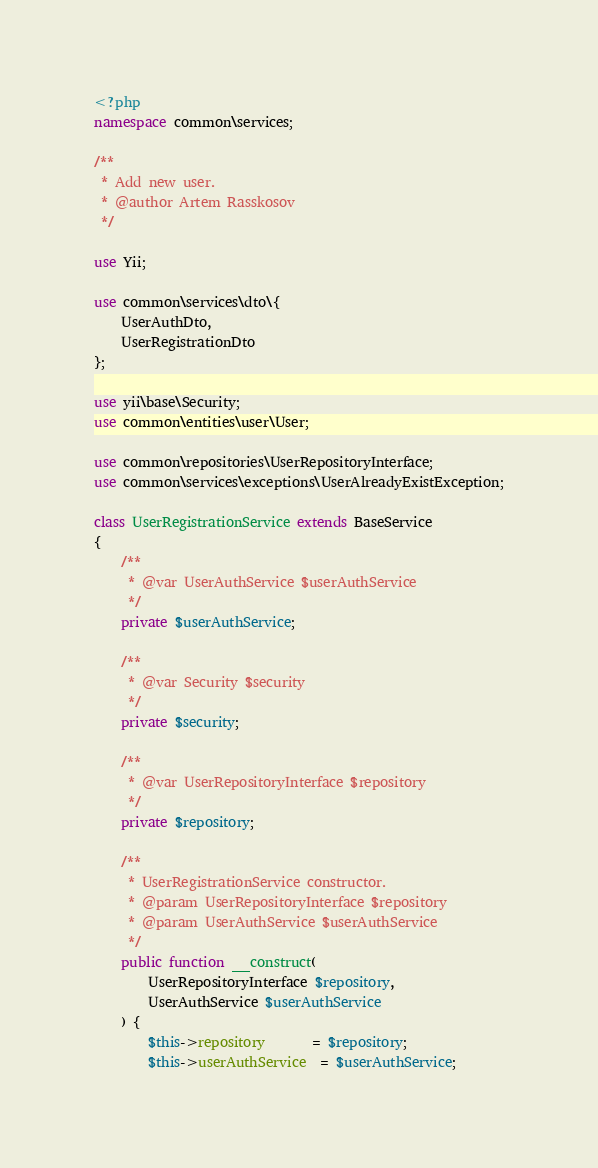Convert code to text. <code><loc_0><loc_0><loc_500><loc_500><_PHP_><?php
namespace common\services;

/**
 * Add new user.
 * @author Artem Rasskosov
 */

use Yii;

use common\services\dto\{
    UserAuthDto,
    UserRegistrationDto
};

use yii\base\Security;
use common\entities\user\User;

use common\repositories\UserRepositoryInterface;
use common\services\exceptions\UserAlreadyExistException;

class UserRegistrationService extends BaseService
{
    /**
     * @var UserAuthService $userAuthService
     */
    private $userAuthService;

    /**
     * @var Security $security
     */
    private $security;

    /**
     * @var UserRepositoryInterface $repository
     */
    private $repository;

    /**
     * UserRegistrationService constructor.
     * @param UserRepositoryInterface $repository
     * @param UserAuthService $userAuthService
     */
    public function __construct(
        UserRepositoryInterface $repository,
        UserAuthService $userAuthService
    ) {
        $this->repository       = $repository;
        $this->userAuthService  = $userAuthService;
</code> 